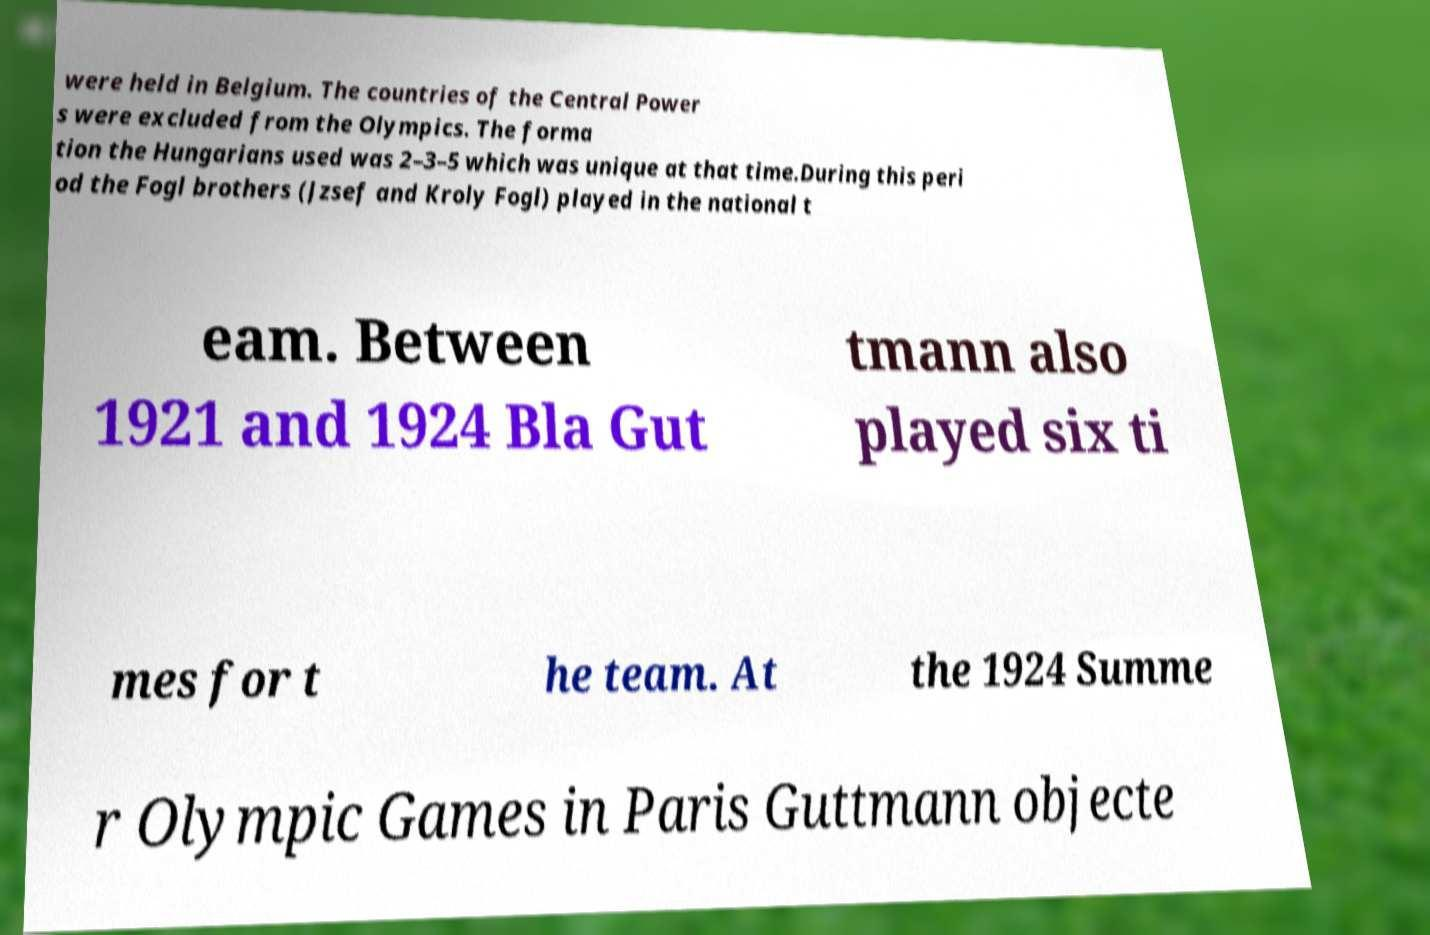Please identify and transcribe the text found in this image. were held in Belgium. The countries of the Central Power s were excluded from the Olympics. The forma tion the Hungarians used was 2–3–5 which was unique at that time.During this peri od the Fogl brothers (Jzsef and Kroly Fogl) played in the national t eam. Between 1921 and 1924 Bla Gut tmann also played six ti mes for t he team. At the 1924 Summe r Olympic Games in Paris Guttmann objecte 